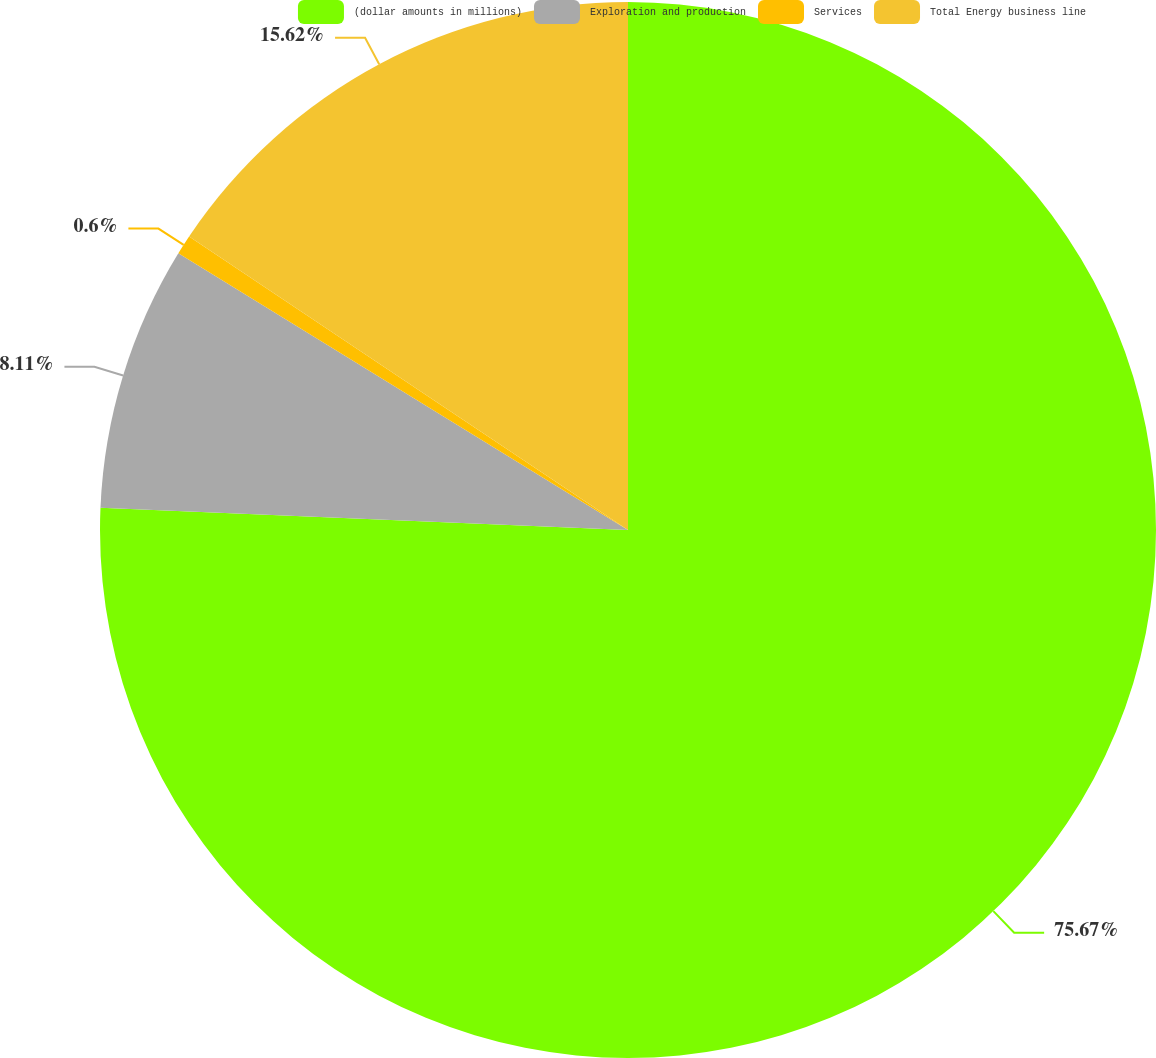<chart> <loc_0><loc_0><loc_500><loc_500><pie_chart><fcel>(dollar amounts in millions)<fcel>Exploration and production<fcel>Services<fcel>Total Energy business line<nl><fcel>75.68%<fcel>8.11%<fcel>0.6%<fcel>15.62%<nl></chart> 